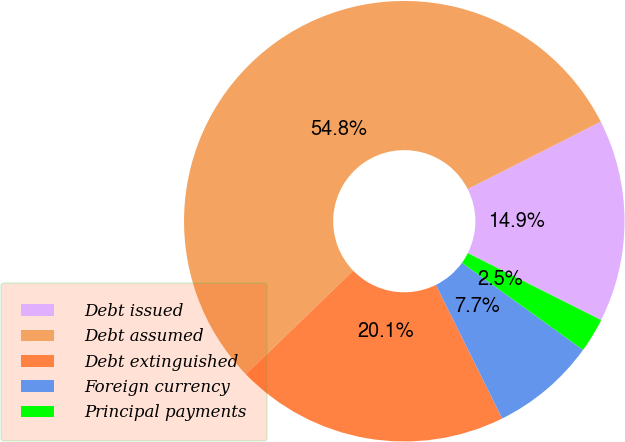Convert chart to OTSL. <chart><loc_0><loc_0><loc_500><loc_500><pie_chart><fcel>Debt issued<fcel>Debt assumed<fcel>Debt extinguished<fcel>Foreign currency<fcel>Principal payments<nl><fcel>14.87%<fcel>54.77%<fcel>20.1%<fcel>7.74%<fcel>2.52%<nl></chart> 